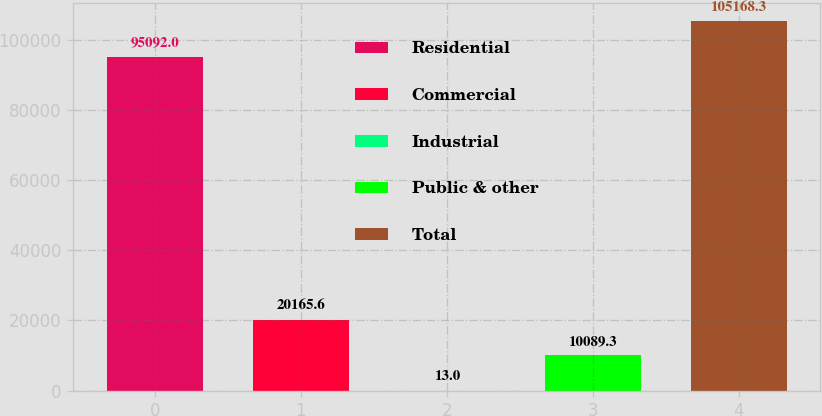Convert chart to OTSL. <chart><loc_0><loc_0><loc_500><loc_500><bar_chart><fcel>Residential<fcel>Commercial<fcel>Industrial<fcel>Public & other<fcel>Total<nl><fcel>95092<fcel>20165.6<fcel>13<fcel>10089.3<fcel>105168<nl></chart> 